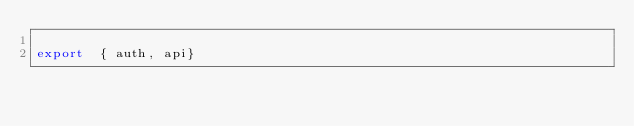Convert code to text. <code><loc_0><loc_0><loc_500><loc_500><_JavaScript_>
export  { auth, api}</code> 